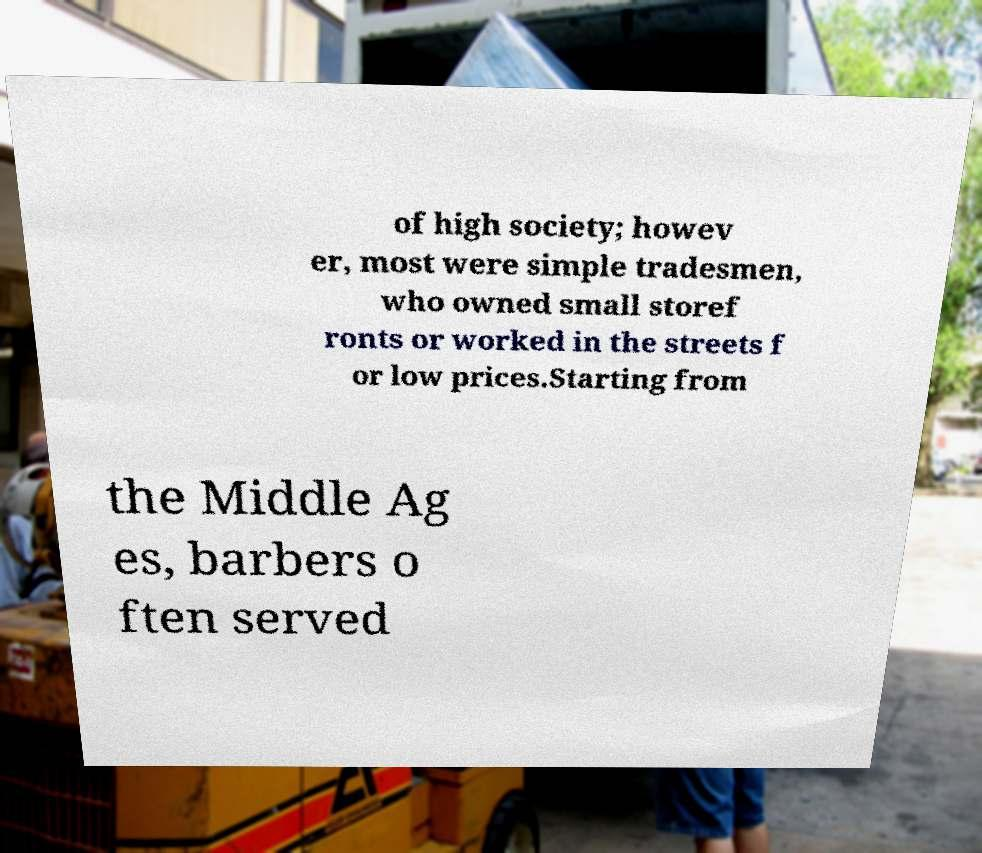There's text embedded in this image that I need extracted. Can you transcribe it verbatim? of high society; howev er, most were simple tradesmen, who owned small storef ronts or worked in the streets f or low prices.Starting from the Middle Ag es, barbers o ften served 